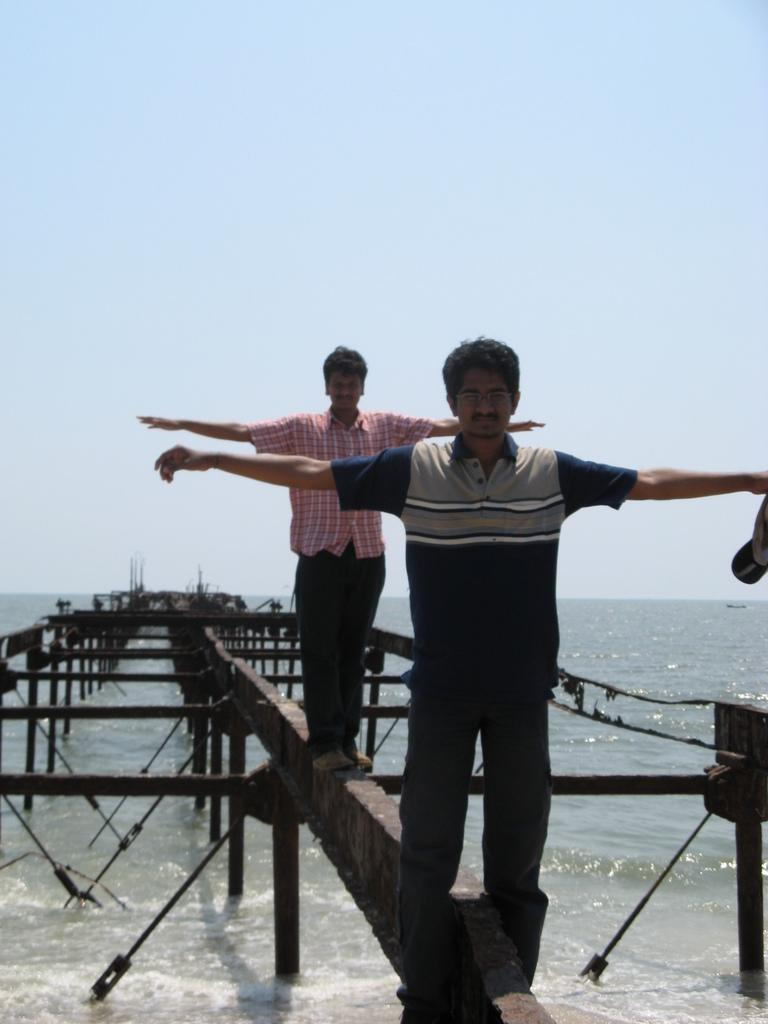How many people are in the image? There are two men standing in the image. What are the men wearing? The men are wearing clothes. What objects can be seen in the image besides the men? There are ropes and metal rods visible in the image. What is the natural element present in the image? There is water visible in the image. What is visible in the background of the image? The sky is visible in the image. What type of cloth is being used to cover the station in the image? There is no cloth or station present in the image. 